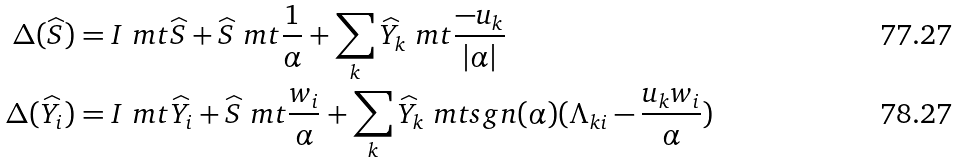Convert formula to latex. <formula><loc_0><loc_0><loc_500><loc_500>\Delta ( \widehat { S } ) & = I \ m t \widehat { S } + \widehat { S } \ m t \frac { 1 } { \alpha } + \sum _ { k } \widehat { Y } _ { k } \ m t \frac { - u _ { k } } { | \alpha | } \\ \Delta ( \widehat { Y } _ { i } ) & = I \ m t \widehat { Y } _ { i } + \widehat { S } \ m t \frac { w _ { i } } { \alpha } + \sum _ { k } \widehat { Y } _ { k } \ m t s g n ( \alpha ) ( \Lambda _ { k i } - \frac { u _ { k } w _ { i } } { \alpha } )</formula> 